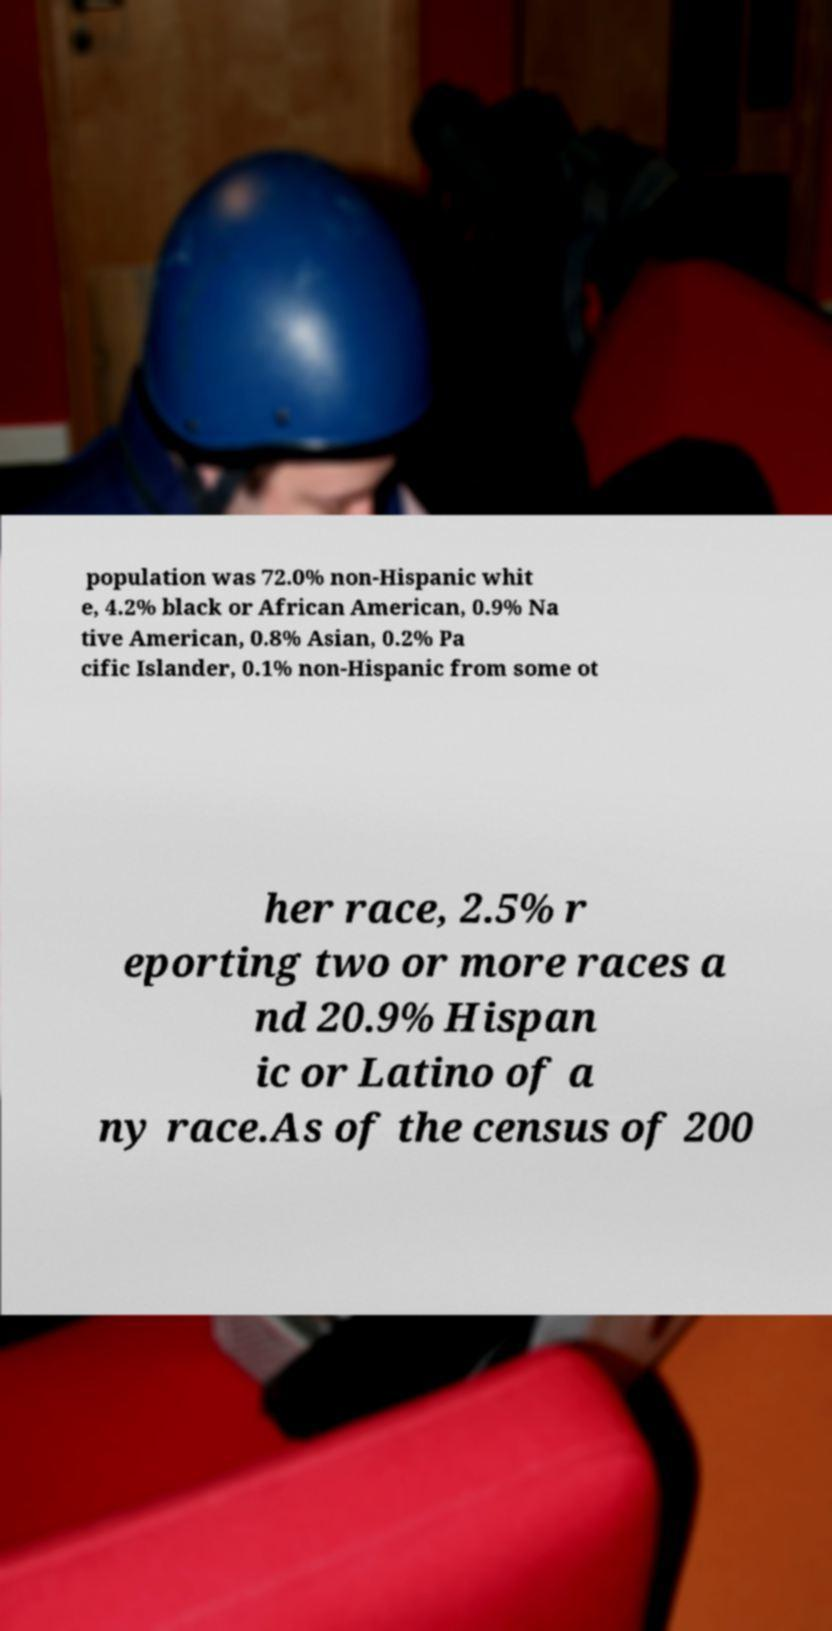I need the written content from this picture converted into text. Can you do that? population was 72.0% non-Hispanic whit e, 4.2% black or African American, 0.9% Na tive American, 0.8% Asian, 0.2% Pa cific Islander, 0.1% non-Hispanic from some ot her race, 2.5% r eporting two or more races a nd 20.9% Hispan ic or Latino of a ny race.As of the census of 200 